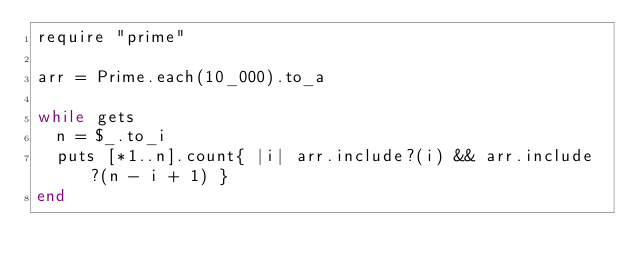Convert code to text. <code><loc_0><loc_0><loc_500><loc_500><_Ruby_>require "prime"

arr = Prime.each(10_000).to_a

while gets
  n = $_.to_i
  puts [*1..n].count{ |i| arr.include?(i) && arr.include?(n - i + 1) }
end</code> 